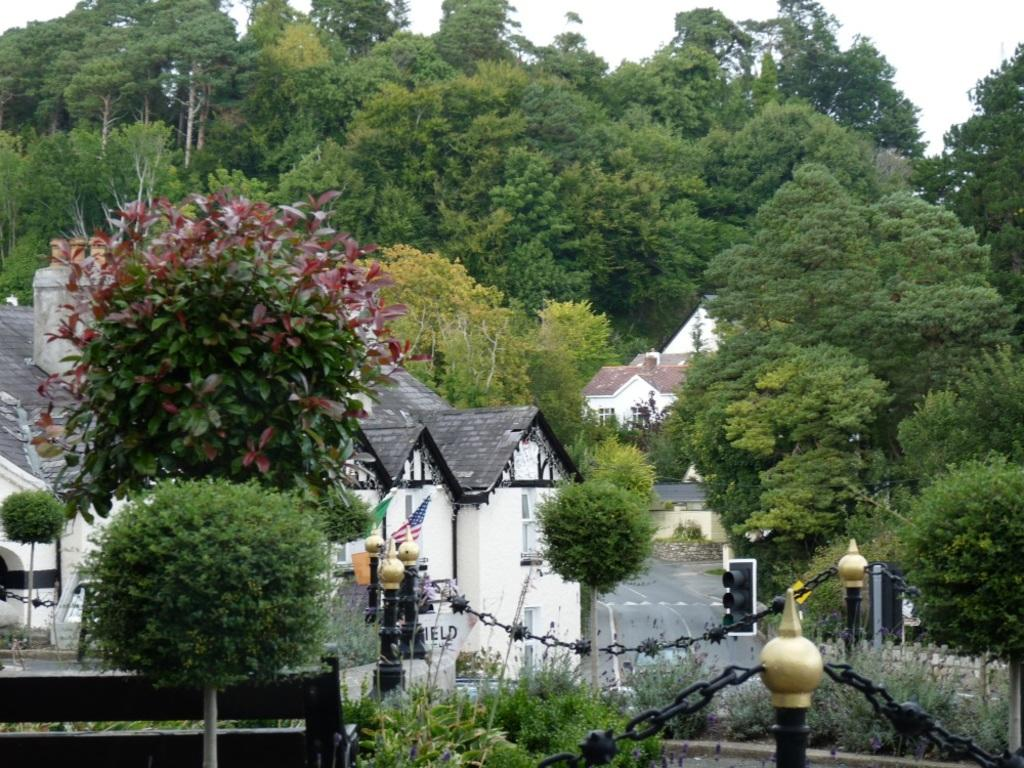What type of natural elements can be seen in the image? There are trees in the image. What type of man-made structures are present in the image? There are houses in the image. What can be seen in the foreground area of the image? It appears to be a boundary in the foreground area of the image, and there is a flag in the foreground area as well. What is visible in the background of the image? There are trees and the sky. Can you tell me how many basketballs are visible in the image? There are no basketballs present in the image. Is there a snail traveling on the boundary in the foreground area of the image? There is no snail visible in the image. 